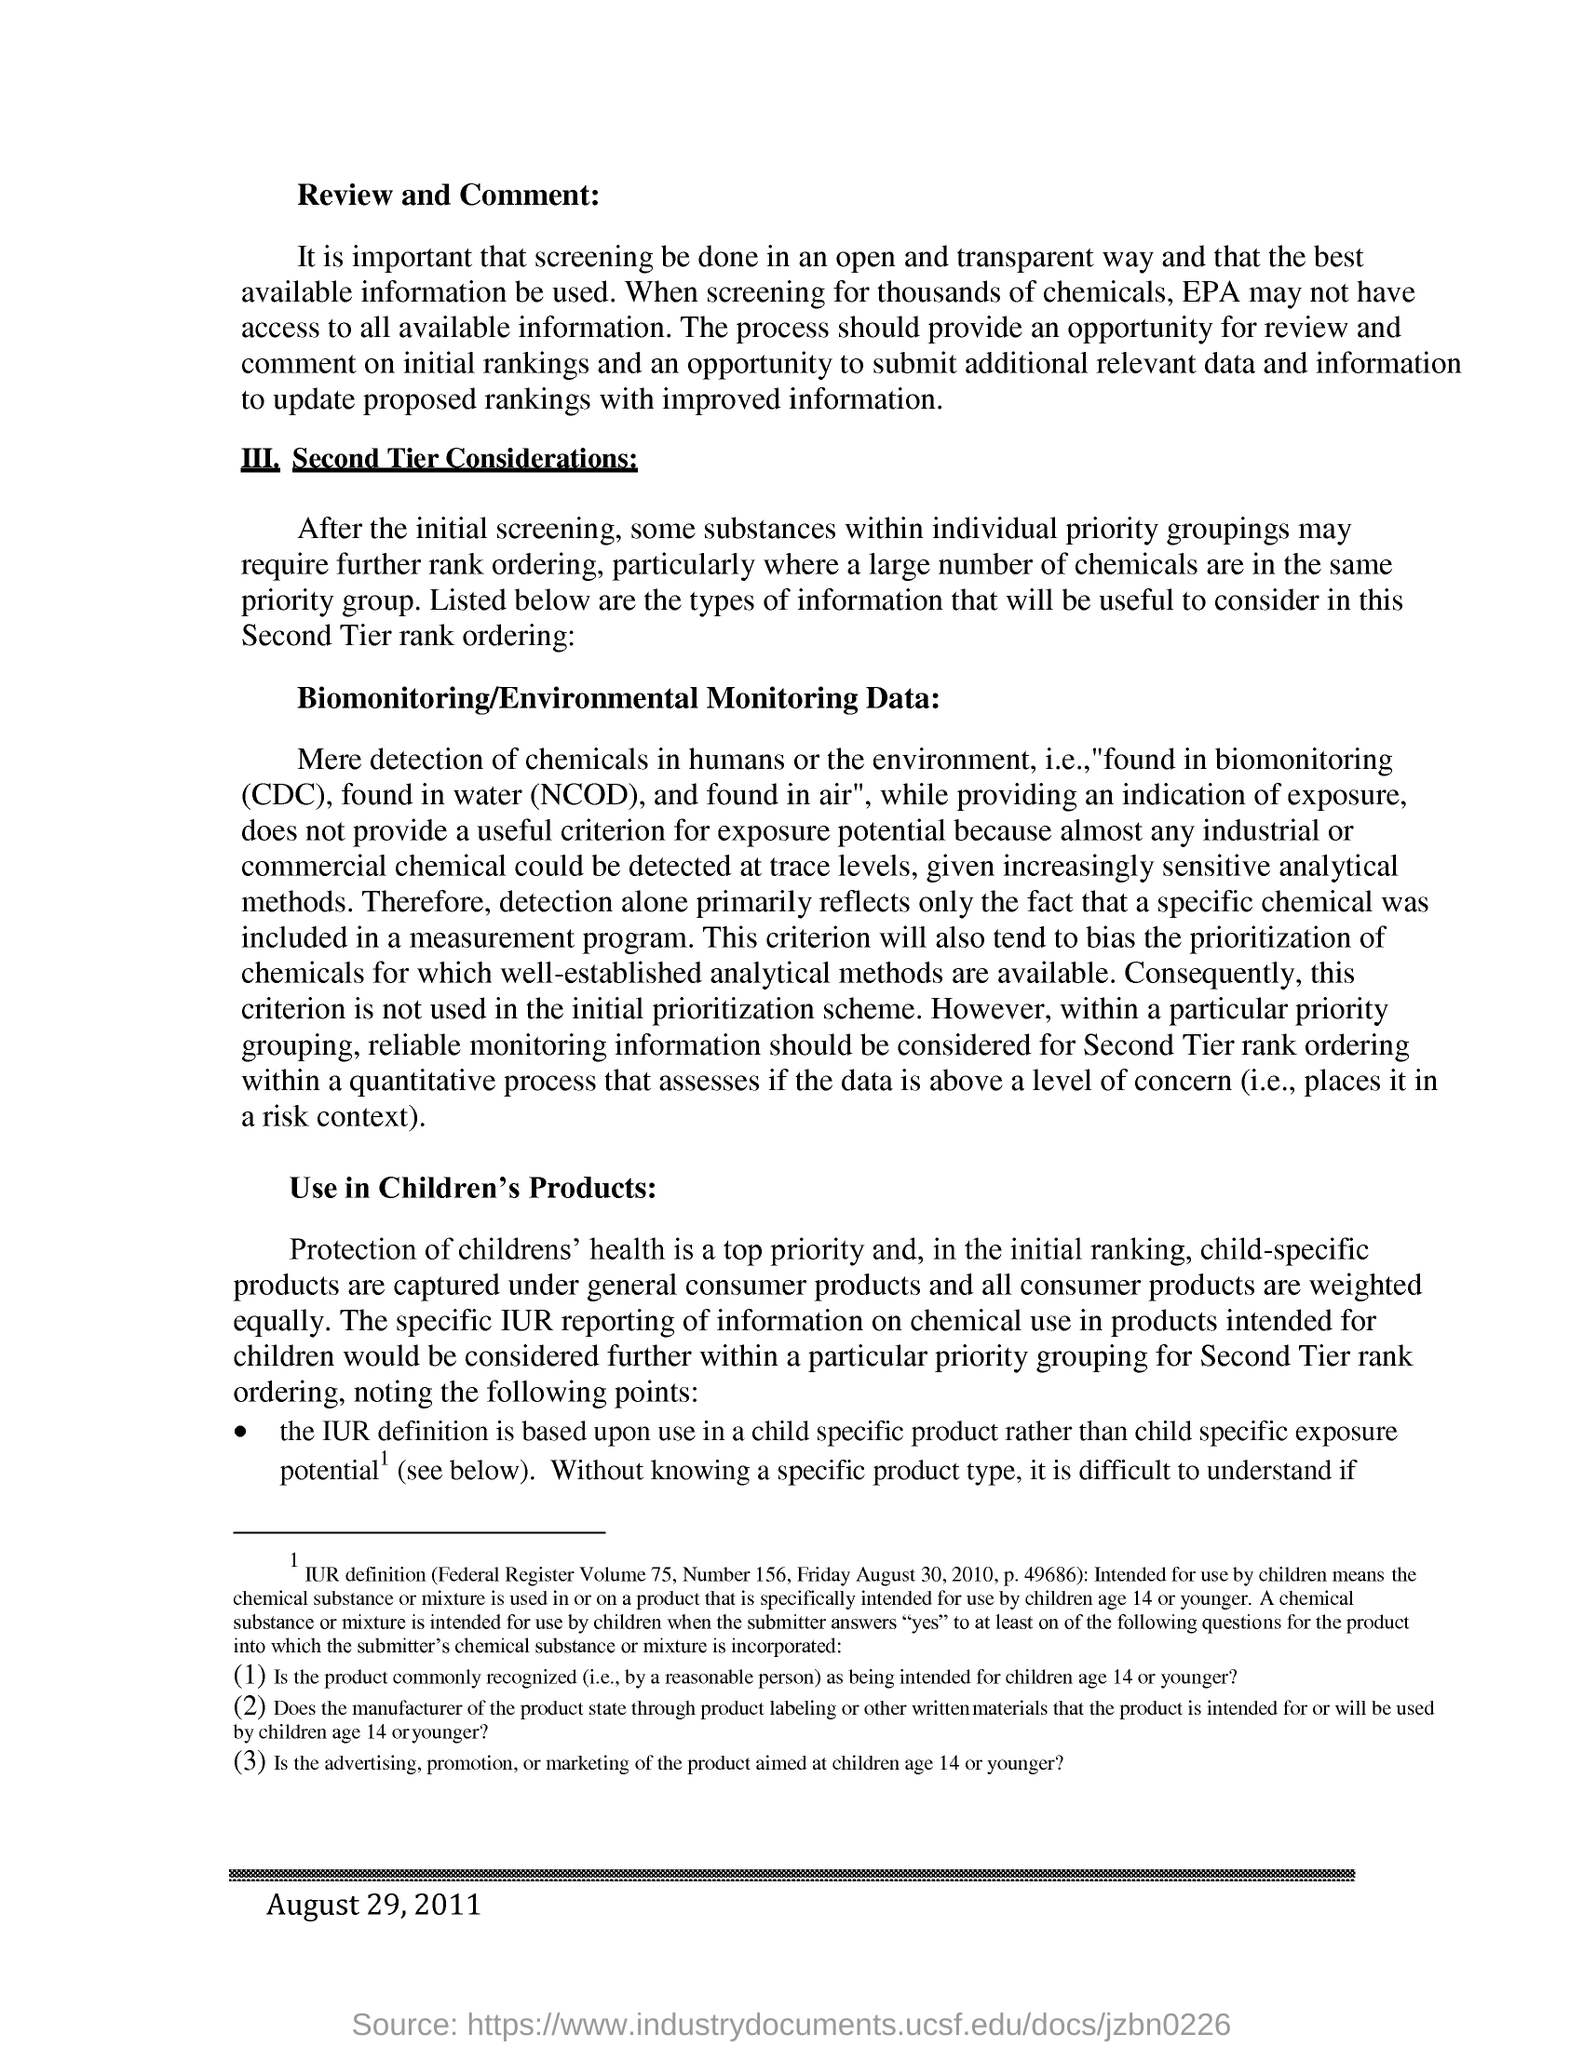Give some essential details in this illustration. The date appearing at the footer of the document is August 29, 2011. 